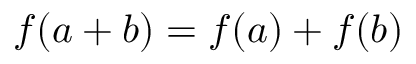Convert formula to latex. <formula><loc_0><loc_0><loc_500><loc_500>f ( a + b ) = f ( a ) + f ( b )</formula> 